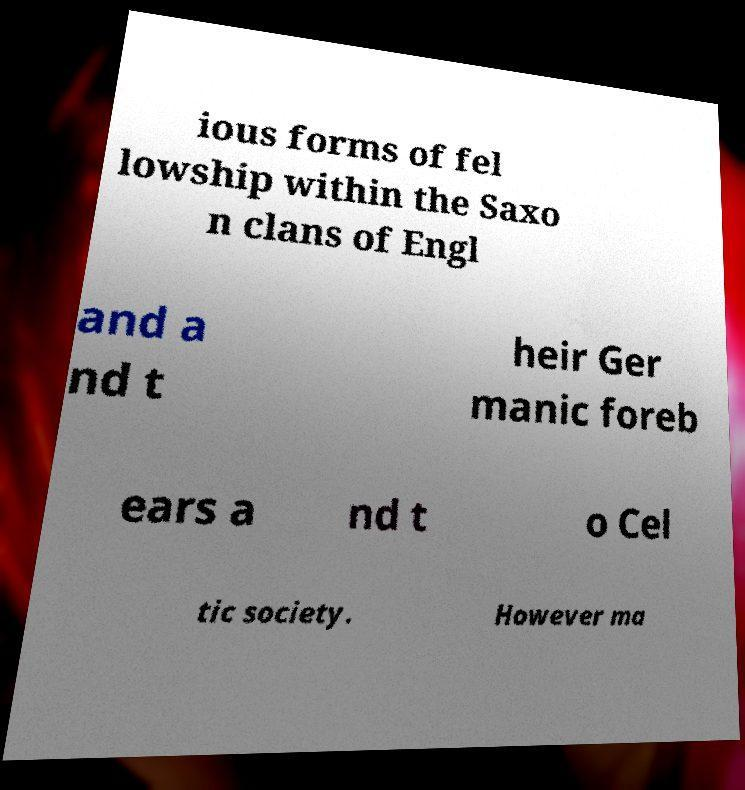Please identify and transcribe the text found in this image. ious forms of fel lowship within the Saxo n clans of Engl and a nd t heir Ger manic foreb ears a nd t o Cel tic society. However ma 